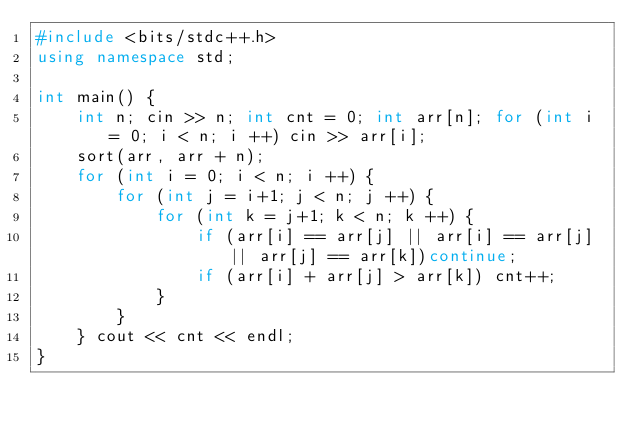Convert code to text. <code><loc_0><loc_0><loc_500><loc_500><_C++_>#include <bits/stdc++.h>
using namespace std; 

int main() {
    int n; cin >> n; int cnt = 0; int arr[n]; for (int i = 0; i < n; i ++) cin >> arr[i];
    sort(arr, arr + n);
    for (int i = 0; i < n; i ++) {
        for (int j = i+1; j < n; j ++) {
            for (int k = j+1; k < n; k ++) {
                if (arr[i] == arr[j] || arr[i] == arr[j] || arr[j] == arr[k])continue;
                if (arr[i] + arr[j] > arr[k]) cnt++;
            }
        }
    } cout << cnt << endl;
}</code> 